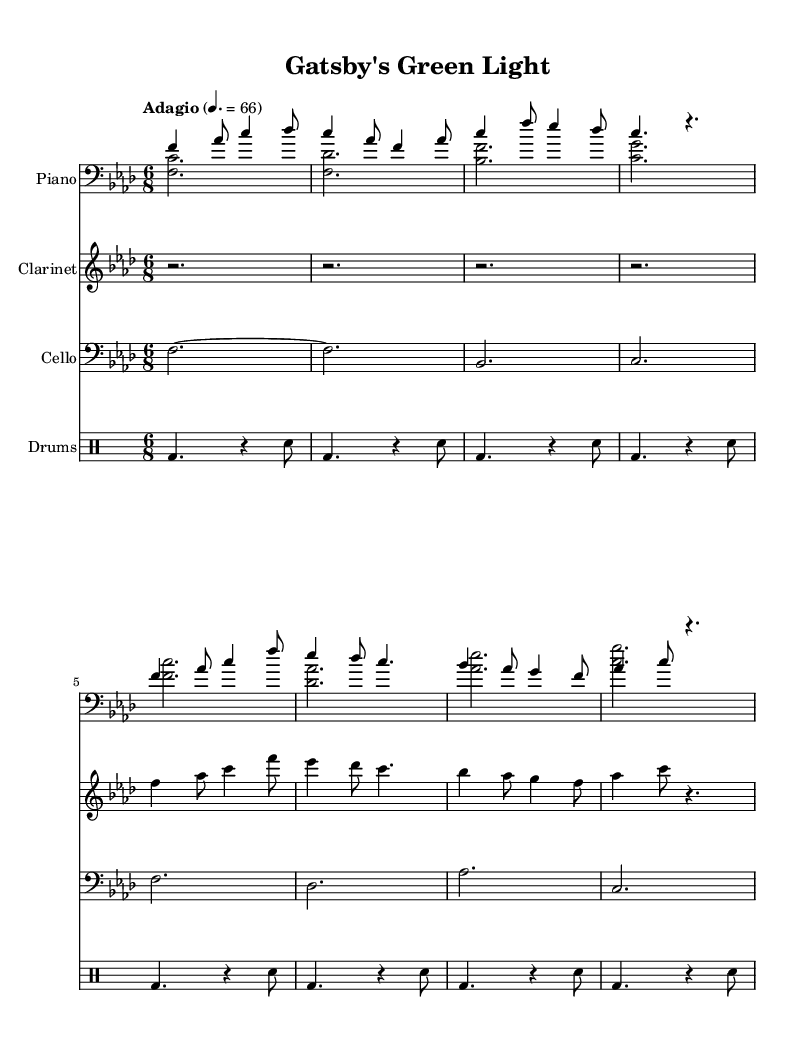What is the key signature of this music? The key signature is indicated in the global section of the sheet music, which shows "f \minor" at the beginning. This means the piece is written in F minor, which typically has four flats.
Answer: F minor What is the time signature of the piece? The time signature is also provided in the global section, where it states "6/8". This indicates that each measure contains six eighth notes, which gives a compound feel to the rhythm.
Answer: 6/8 What is the tempo marking for the piece? The tempo marking appears in the global section as "Adagio" followed by "4. = 66". "Adagio" suggests a slow tempo, and "4. = 66" indicates that the quarter note should be played at 66 beats per minute.
Answer: Adagio, 66 How many measures are in the piano part? In looking at the music sheet, the piano part consists of a total of 16 measures, as evidenced by counting the groupings of notes separated by bar lines.
Answer: 16 Which instruments are included in this fusion piece? Upon reviewing the score, we see parts for Piano, Clarinet, Cello, and Drums, as each instrument is designated under its own staff, indicating that these four instruments are featured throughout the piece.
Answer: Piano, Clarinet, Cello, Drums What rhythmic pattern is primarily used in the drum part? The drum part consistently uses a rhythmic pattern that combines a bass drum followed by a snare drum in an alternating fashion, primarily consisting of eighth notes and rests, which contributes to the overall rhythmic drive.
Answer: Bass drum, snare drum What is the theme of this fusion piece? The title "Gatsby's Green Light" suggests thematic inspiration drawn from F. Scott Fitzgerald's "The Great Gatsby," focusing on introspective elements that explore the characters' inner lives, particularly the longing and desire that are central to the narrative.
Answer: Introspection, longing 